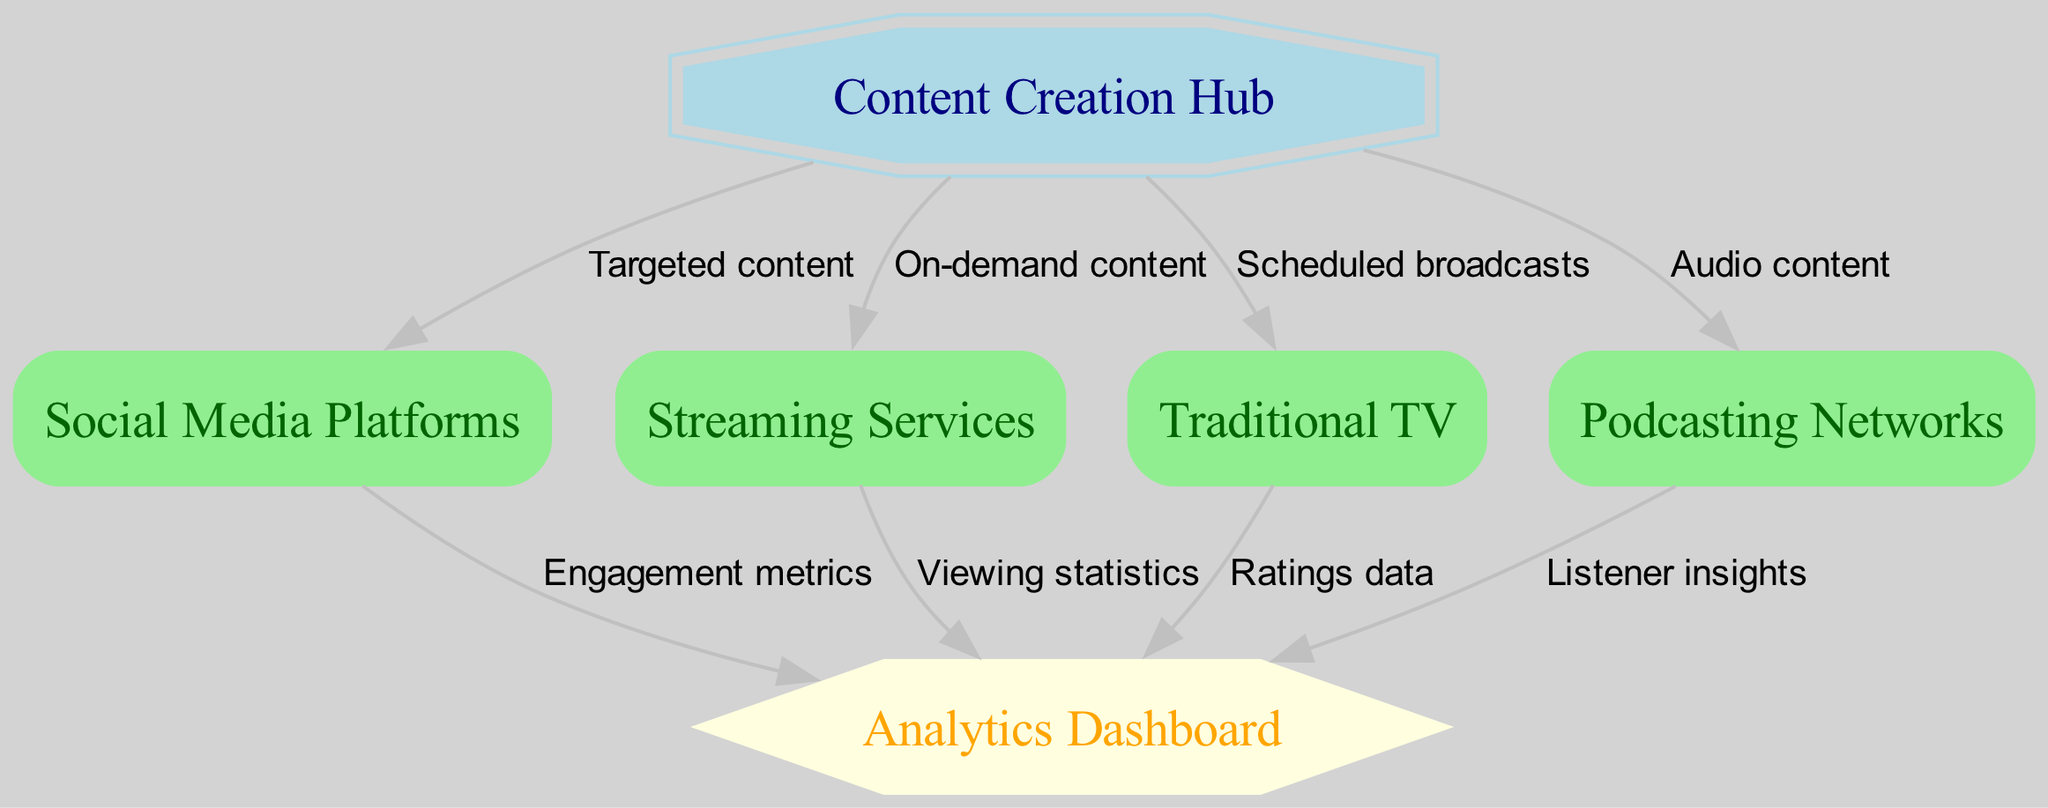What is the central node in the diagram? The central node is labeled "Content Creation Hub," which acts as the main source for distributing content to various channels.
Answer: Content Creation Hub How many distribution channels are present in the diagram? There are four distribution channels mentioned: Social Media Platforms, Streaming Services, Traditional TV, and Podcasting Networks. By counting each unique channel listed, we find the total is four.
Answer: 4 What is the label for the edge connecting the Content Creation Hub to Streaming Services? The edge connecting these two nodes is labeled "On-demand content," indicating the type of content distributed to this channel.
Answer: On-demand content Which node receives engagement metrics from Social Media Platforms? The Analytics Dashboard is the node that receives engagement metrics from Social Media Platforms, as indicated by the directed edge leading from node 2 to node 6 labeled accordingly.
Answer: Analytics Dashboard How many metrics are monitored from the streaming services? One metric is monitored, which is "Viewing statistics." This is the only connection that leads from Streaming Services to the Analytics Dashboard.
Answer: 1 Which distribution channel shares listener insights with the Analytics Dashboard? Podcasting Networks are the distribution channel that provides listener insights to the Analytics Dashboard, as indicated by the edge labeled "Listener insights."
Answer: Podcasting Networks What content type is associated with the edge connecting Content Creation Hub and Traditional TV? The edge is labeled "Scheduled broadcasts," which specifies the type of content shared with the Traditional TV distribution channel.
Answer: Scheduled broadcasts What type of node is the Analytics Dashboard classified as? The Analytics Dashboard is classified as a "Monitoring Tool," which shows its role in tracking various audience metrics from different distribution channels.
Answer: Monitoring Tool Which distribution channel is NOT directly linked to Content Creation Hub? All listed channels are directly linked; however, if you ask about additional channels in practice, Channels outside of the provided diagram may not be linked. Since all in the data are linked, the answer remains none.
Answer: None 